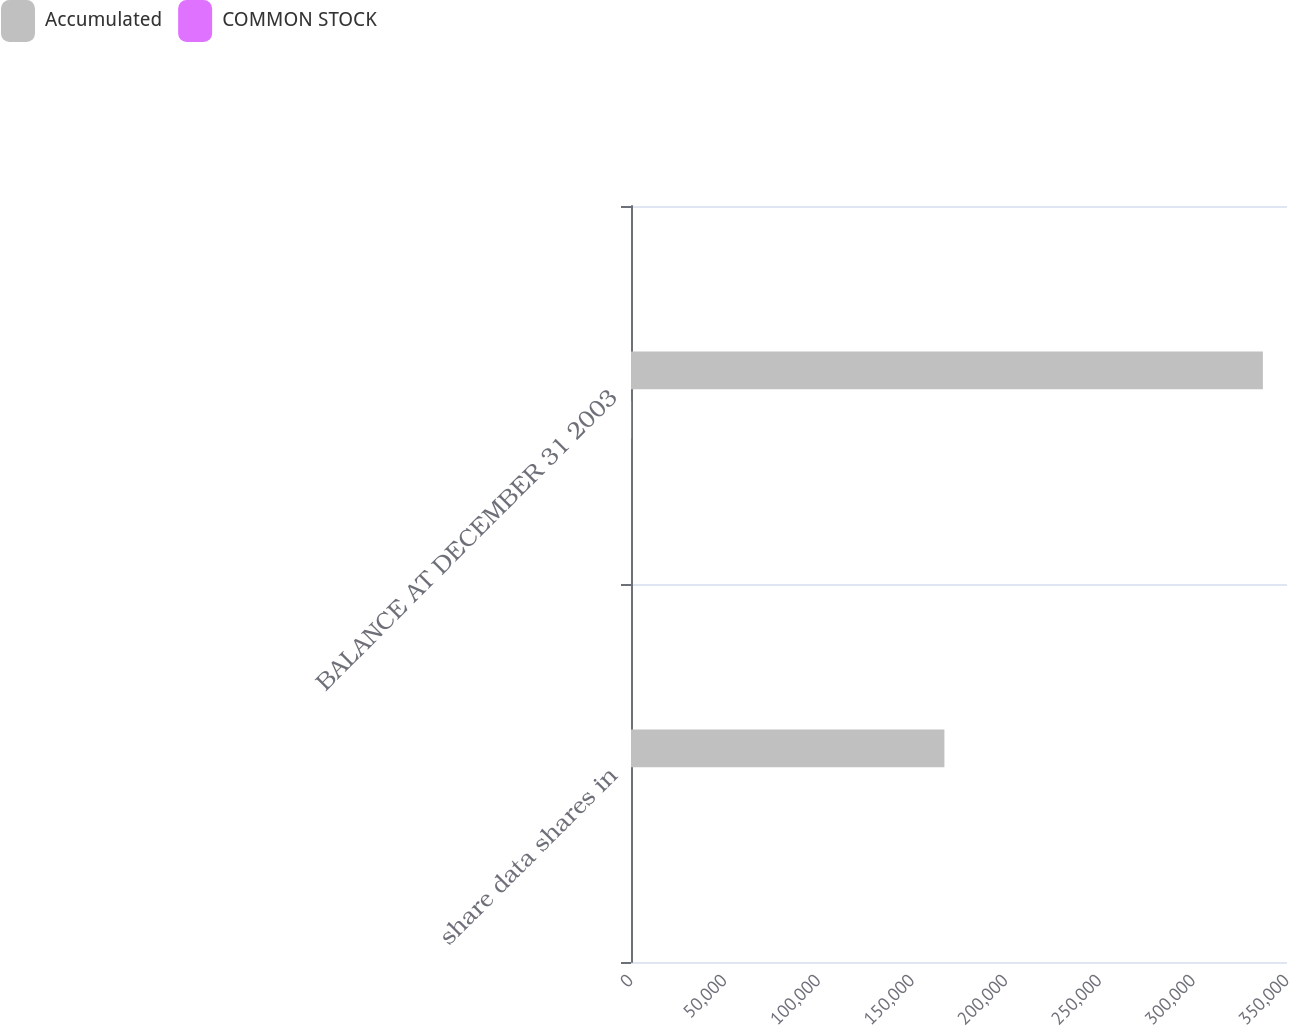<chart> <loc_0><loc_0><loc_500><loc_500><stacked_bar_chart><ecel><fcel>share data shares in<fcel>BALANCE AT DECEMBER 31 2003<nl><fcel>Accumulated<fcel>167219<fcel>337132<nl><fcel>COMMON STOCK<fcel>1<fcel>192<nl></chart> 